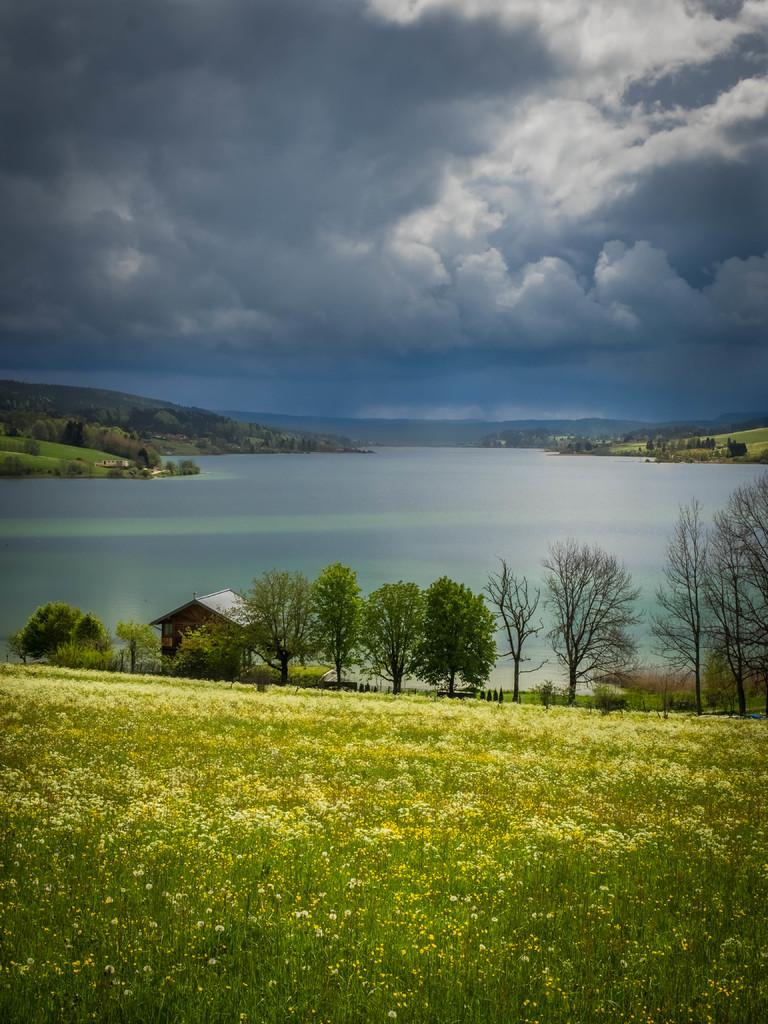What structure is located on the left side of the image? There is a house on the left side of the image. What natural element is visible in the image? There is water visible in the image. How would you describe the sky in the image? The sky is cloudy in the image. What type of vegetation can be seen in the middle of the image? There are trees in the middle of the image. Where is the quartz located in the image? There is no quartz present in the image. What type of sink can be seen in the image? There is no sink present in the image. 